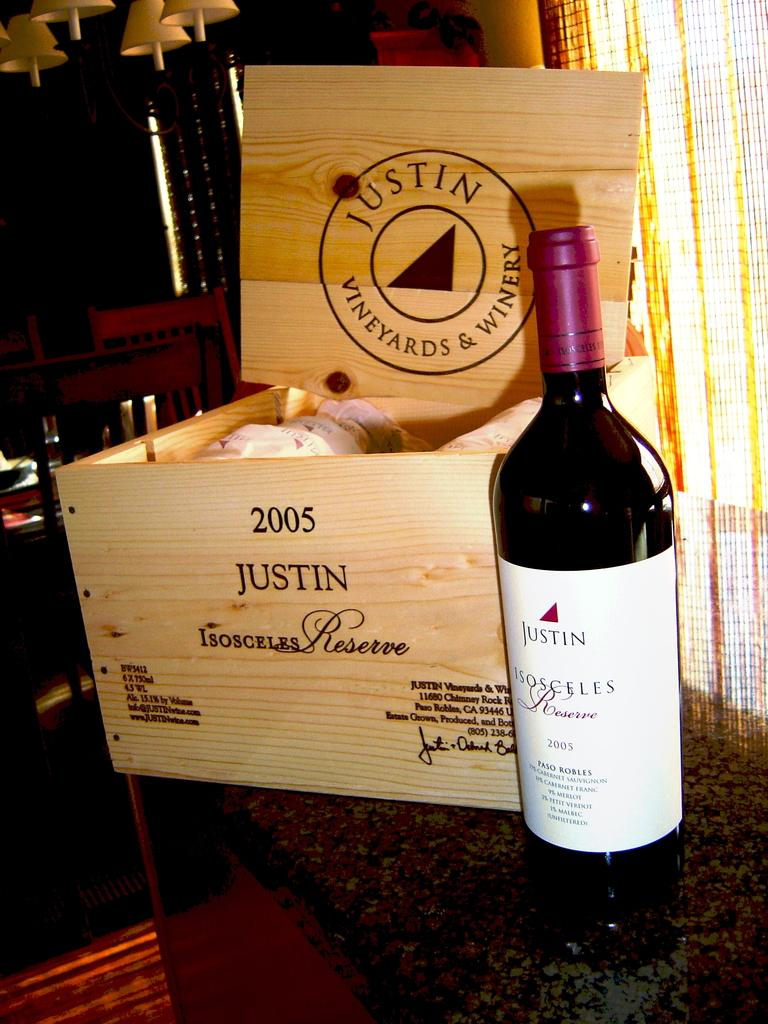<image>
Write a terse but informative summary of the picture. a bottle of Justin wine is sitting by a wooden case of the same 